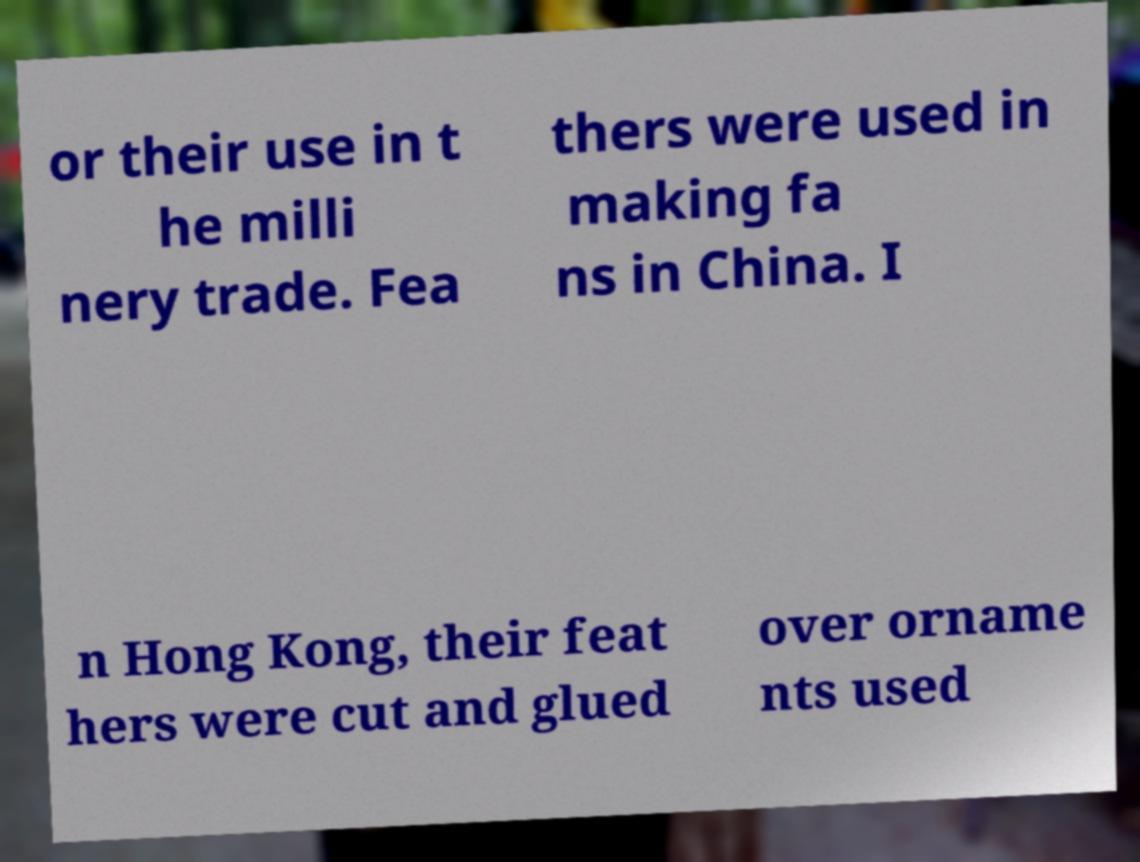Could you assist in decoding the text presented in this image and type it out clearly? or their use in t he milli nery trade. Fea thers were used in making fa ns in China. I n Hong Kong, their feat hers were cut and glued over orname nts used 